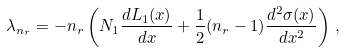<formula> <loc_0><loc_0><loc_500><loc_500>\lambda _ { n _ { r } } = - n _ { r } \left ( N _ { 1 } \frac { d L _ { 1 } ( x ) } { d x } + \frac { 1 } { 2 } ( n _ { r } - 1 ) \frac { d ^ { 2 } \sigma ( x ) } { d x ^ { 2 } } \right ) \, ,</formula> 